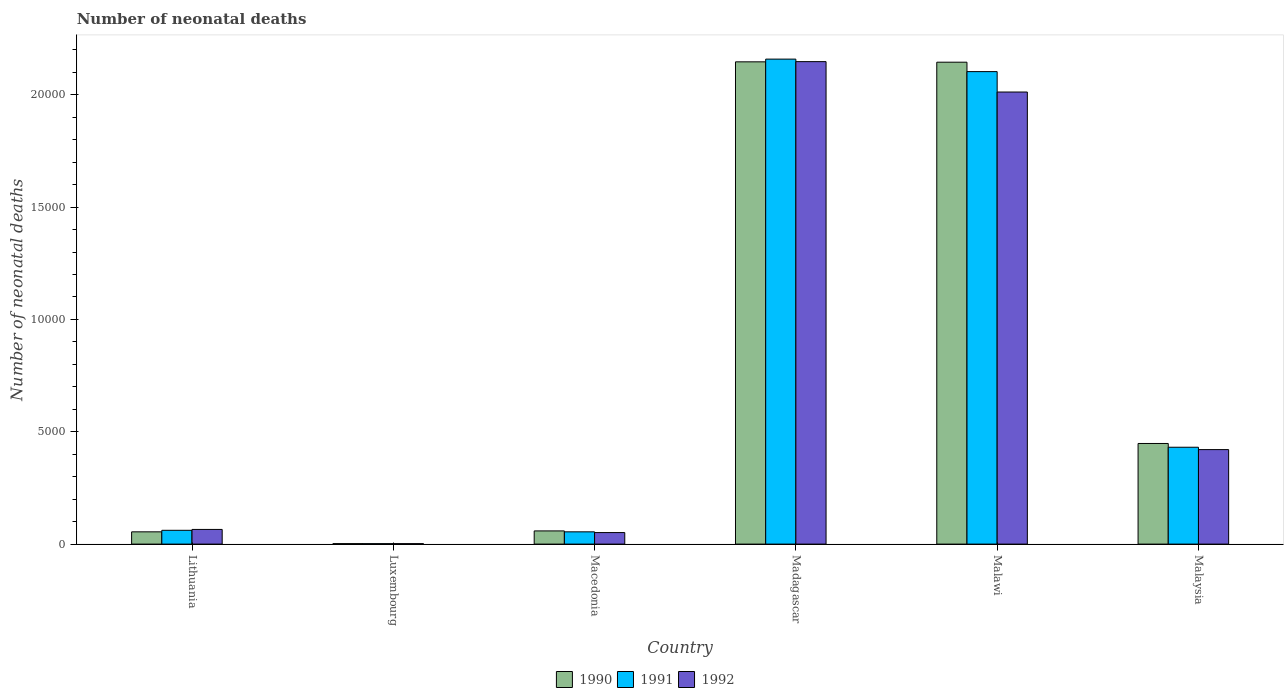How many different coloured bars are there?
Give a very brief answer. 3. How many bars are there on the 2nd tick from the right?
Keep it short and to the point. 3. What is the label of the 2nd group of bars from the left?
Ensure brevity in your answer.  Luxembourg. In how many cases, is the number of bars for a given country not equal to the number of legend labels?
Keep it short and to the point. 0. What is the number of neonatal deaths in in 1991 in Malawi?
Make the answer very short. 2.10e+04. Across all countries, what is the maximum number of neonatal deaths in in 1990?
Ensure brevity in your answer.  2.15e+04. Across all countries, what is the minimum number of neonatal deaths in in 1991?
Provide a succinct answer. 20. In which country was the number of neonatal deaths in in 1990 maximum?
Offer a very short reply. Madagascar. In which country was the number of neonatal deaths in in 1992 minimum?
Your response must be concise. Luxembourg. What is the total number of neonatal deaths in in 1991 in the graph?
Make the answer very short. 4.81e+04. What is the difference between the number of neonatal deaths in in 1990 in Luxembourg and that in Malawi?
Make the answer very short. -2.14e+04. What is the difference between the number of neonatal deaths in in 1991 in Macedonia and the number of neonatal deaths in in 1992 in Lithuania?
Your response must be concise. -107. What is the average number of neonatal deaths in in 1991 per country?
Give a very brief answer. 8017.83. What is the difference between the number of neonatal deaths in of/in 1991 and number of neonatal deaths in of/in 1990 in Malawi?
Provide a short and direct response. -419. In how many countries, is the number of neonatal deaths in in 1991 greater than 10000?
Provide a short and direct response. 2. What is the ratio of the number of neonatal deaths in in 1990 in Macedonia to that in Madagascar?
Your response must be concise. 0.03. Is the number of neonatal deaths in in 1992 in Lithuania less than that in Malawi?
Offer a terse response. Yes. Is the difference between the number of neonatal deaths in in 1991 in Lithuania and Madagascar greater than the difference between the number of neonatal deaths in in 1990 in Lithuania and Madagascar?
Provide a short and direct response. No. What is the difference between the highest and the second highest number of neonatal deaths in in 1990?
Your answer should be very brief. 16. What is the difference between the highest and the lowest number of neonatal deaths in in 1992?
Provide a succinct answer. 2.15e+04. Is the sum of the number of neonatal deaths in in 1990 in Madagascar and Malaysia greater than the maximum number of neonatal deaths in in 1991 across all countries?
Provide a succinct answer. Yes. Does the graph contain grids?
Give a very brief answer. No. How many legend labels are there?
Provide a succinct answer. 3. What is the title of the graph?
Provide a succinct answer. Number of neonatal deaths. Does "2002" appear as one of the legend labels in the graph?
Provide a short and direct response. No. What is the label or title of the X-axis?
Your answer should be very brief. Country. What is the label or title of the Y-axis?
Ensure brevity in your answer.  Number of neonatal deaths. What is the Number of neonatal deaths of 1990 in Lithuania?
Your answer should be very brief. 546. What is the Number of neonatal deaths in 1991 in Lithuania?
Your response must be concise. 614. What is the Number of neonatal deaths of 1992 in Lithuania?
Offer a terse response. 653. What is the Number of neonatal deaths of 1990 in Luxembourg?
Provide a short and direct response. 21. What is the Number of neonatal deaths in 1990 in Macedonia?
Provide a short and direct response. 587. What is the Number of neonatal deaths of 1991 in Macedonia?
Your answer should be compact. 546. What is the Number of neonatal deaths of 1992 in Macedonia?
Your response must be concise. 513. What is the Number of neonatal deaths in 1990 in Madagascar?
Provide a succinct answer. 2.15e+04. What is the Number of neonatal deaths in 1991 in Madagascar?
Provide a succinct answer. 2.16e+04. What is the Number of neonatal deaths in 1992 in Madagascar?
Offer a very short reply. 2.15e+04. What is the Number of neonatal deaths of 1990 in Malawi?
Your response must be concise. 2.14e+04. What is the Number of neonatal deaths in 1991 in Malawi?
Your answer should be very brief. 2.10e+04. What is the Number of neonatal deaths of 1992 in Malawi?
Give a very brief answer. 2.01e+04. What is the Number of neonatal deaths in 1990 in Malaysia?
Your answer should be compact. 4479. What is the Number of neonatal deaths of 1991 in Malaysia?
Keep it short and to the point. 4311. What is the Number of neonatal deaths in 1992 in Malaysia?
Your answer should be very brief. 4206. Across all countries, what is the maximum Number of neonatal deaths of 1990?
Ensure brevity in your answer.  2.15e+04. Across all countries, what is the maximum Number of neonatal deaths in 1991?
Provide a succinct answer. 2.16e+04. Across all countries, what is the maximum Number of neonatal deaths of 1992?
Your response must be concise. 2.15e+04. Across all countries, what is the minimum Number of neonatal deaths of 1990?
Offer a terse response. 21. Across all countries, what is the minimum Number of neonatal deaths of 1992?
Provide a short and direct response. 20. What is the total Number of neonatal deaths of 1990 in the graph?
Provide a short and direct response. 4.85e+04. What is the total Number of neonatal deaths in 1991 in the graph?
Keep it short and to the point. 4.81e+04. What is the total Number of neonatal deaths in 1992 in the graph?
Offer a very short reply. 4.70e+04. What is the difference between the Number of neonatal deaths of 1990 in Lithuania and that in Luxembourg?
Make the answer very short. 525. What is the difference between the Number of neonatal deaths of 1991 in Lithuania and that in Luxembourg?
Your response must be concise. 594. What is the difference between the Number of neonatal deaths of 1992 in Lithuania and that in Luxembourg?
Provide a short and direct response. 633. What is the difference between the Number of neonatal deaths of 1990 in Lithuania and that in Macedonia?
Provide a short and direct response. -41. What is the difference between the Number of neonatal deaths in 1992 in Lithuania and that in Macedonia?
Your answer should be compact. 140. What is the difference between the Number of neonatal deaths in 1990 in Lithuania and that in Madagascar?
Your answer should be compact. -2.09e+04. What is the difference between the Number of neonatal deaths of 1991 in Lithuania and that in Madagascar?
Provide a succinct answer. -2.10e+04. What is the difference between the Number of neonatal deaths of 1992 in Lithuania and that in Madagascar?
Offer a very short reply. -2.08e+04. What is the difference between the Number of neonatal deaths in 1990 in Lithuania and that in Malawi?
Provide a short and direct response. -2.09e+04. What is the difference between the Number of neonatal deaths of 1991 in Lithuania and that in Malawi?
Keep it short and to the point. -2.04e+04. What is the difference between the Number of neonatal deaths in 1992 in Lithuania and that in Malawi?
Your response must be concise. -1.95e+04. What is the difference between the Number of neonatal deaths of 1990 in Lithuania and that in Malaysia?
Make the answer very short. -3933. What is the difference between the Number of neonatal deaths in 1991 in Lithuania and that in Malaysia?
Make the answer very short. -3697. What is the difference between the Number of neonatal deaths in 1992 in Lithuania and that in Malaysia?
Offer a terse response. -3553. What is the difference between the Number of neonatal deaths of 1990 in Luxembourg and that in Macedonia?
Provide a succinct answer. -566. What is the difference between the Number of neonatal deaths in 1991 in Luxembourg and that in Macedonia?
Ensure brevity in your answer.  -526. What is the difference between the Number of neonatal deaths in 1992 in Luxembourg and that in Macedonia?
Keep it short and to the point. -493. What is the difference between the Number of neonatal deaths of 1990 in Luxembourg and that in Madagascar?
Your response must be concise. -2.14e+04. What is the difference between the Number of neonatal deaths in 1991 in Luxembourg and that in Madagascar?
Your answer should be very brief. -2.16e+04. What is the difference between the Number of neonatal deaths in 1992 in Luxembourg and that in Madagascar?
Keep it short and to the point. -2.15e+04. What is the difference between the Number of neonatal deaths in 1990 in Luxembourg and that in Malawi?
Provide a succinct answer. -2.14e+04. What is the difference between the Number of neonatal deaths of 1991 in Luxembourg and that in Malawi?
Your answer should be compact. -2.10e+04. What is the difference between the Number of neonatal deaths of 1992 in Luxembourg and that in Malawi?
Ensure brevity in your answer.  -2.01e+04. What is the difference between the Number of neonatal deaths of 1990 in Luxembourg and that in Malaysia?
Make the answer very short. -4458. What is the difference between the Number of neonatal deaths of 1991 in Luxembourg and that in Malaysia?
Your answer should be very brief. -4291. What is the difference between the Number of neonatal deaths in 1992 in Luxembourg and that in Malaysia?
Make the answer very short. -4186. What is the difference between the Number of neonatal deaths of 1990 in Macedonia and that in Madagascar?
Provide a short and direct response. -2.09e+04. What is the difference between the Number of neonatal deaths of 1991 in Macedonia and that in Madagascar?
Provide a short and direct response. -2.10e+04. What is the difference between the Number of neonatal deaths in 1992 in Macedonia and that in Madagascar?
Offer a very short reply. -2.10e+04. What is the difference between the Number of neonatal deaths of 1990 in Macedonia and that in Malawi?
Make the answer very short. -2.09e+04. What is the difference between the Number of neonatal deaths of 1991 in Macedonia and that in Malawi?
Your response must be concise. -2.05e+04. What is the difference between the Number of neonatal deaths of 1992 in Macedonia and that in Malawi?
Make the answer very short. -1.96e+04. What is the difference between the Number of neonatal deaths of 1990 in Macedonia and that in Malaysia?
Your response must be concise. -3892. What is the difference between the Number of neonatal deaths in 1991 in Macedonia and that in Malaysia?
Your answer should be very brief. -3765. What is the difference between the Number of neonatal deaths in 1992 in Macedonia and that in Malaysia?
Offer a very short reply. -3693. What is the difference between the Number of neonatal deaths of 1991 in Madagascar and that in Malawi?
Provide a succinct answer. 556. What is the difference between the Number of neonatal deaths of 1992 in Madagascar and that in Malawi?
Your answer should be compact. 1352. What is the difference between the Number of neonatal deaths of 1990 in Madagascar and that in Malaysia?
Provide a short and direct response. 1.70e+04. What is the difference between the Number of neonatal deaths of 1991 in Madagascar and that in Malaysia?
Provide a succinct answer. 1.73e+04. What is the difference between the Number of neonatal deaths in 1992 in Madagascar and that in Malaysia?
Keep it short and to the point. 1.73e+04. What is the difference between the Number of neonatal deaths of 1990 in Malawi and that in Malaysia?
Offer a very short reply. 1.70e+04. What is the difference between the Number of neonatal deaths of 1991 in Malawi and that in Malaysia?
Offer a terse response. 1.67e+04. What is the difference between the Number of neonatal deaths of 1992 in Malawi and that in Malaysia?
Keep it short and to the point. 1.59e+04. What is the difference between the Number of neonatal deaths in 1990 in Lithuania and the Number of neonatal deaths in 1991 in Luxembourg?
Give a very brief answer. 526. What is the difference between the Number of neonatal deaths of 1990 in Lithuania and the Number of neonatal deaths of 1992 in Luxembourg?
Offer a very short reply. 526. What is the difference between the Number of neonatal deaths of 1991 in Lithuania and the Number of neonatal deaths of 1992 in Luxembourg?
Provide a succinct answer. 594. What is the difference between the Number of neonatal deaths in 1990 in Lithuania and the Number of neonatal deaths in 1991 in Macedonia?
Give a very brief answer. 0. What is the difference between the Number of neonatal deaths in 1991 in Lithuania and the Number of neonatal deaths in 1992 in Macedonia?
Provide a short and direct response. 101. What is the difference between the Number of neonatal deaths in 1990 in Lithuania and the Number of neonatal deaths in 1991 in Madagascar?
Your answer should be very brief. -2.10e+04. What is the difference between the Number of neonatal deaths in 1990 in Lithuania and the Number of neonatal deaths in 1992 in Madagascar?
Give a very brief answer. -2.09e+04. What is the difference between the Number of neonatal deaths in 1991 in Lithuania and the Number of neonatal deaths in 1992 in Madagascar?
Make the answer very short. -2.09e+04. What is the difference between the Number of neonatal deaths in 1990 in Lithuania and the Number of neonatal deaths in 1991 in Malawi?
Give a very brief answer. -2.05e+04. What is the difference between the Number of neonatal deaths of 1990 in Lithuania and the Number of neonatal deaths of 1992 in Malawi?
Offer a very short reply. -1.96e+04. What is the difference between the Number of neonatal deaths in 1991 in Lithuania and the Number of neonatal deaths in 1992 in Malawi?
Your answer should be very brief. -1.95e+04. What is the difference between the Number of neonatal deaths in 1990 in Lithuania and the Number of neonatal deaths in 1991 in Malaysia?
Give a very brief answer. -3765. What is the difference between the Number of neonatal deaths of 1990 in Lithuania and the Number of neonatal deaths of 1992 in Malaysia?
Offer a very short reply. -3660. What is the difference between the Number of neonatal deaths in 1991 in Lithuania and the Number of neonatal deaths in 1992 in Malaysia?
Your answer should be compact. -3592. What is the difference between the Number of neonatal deaths of 1990 in Luxembourg and the Number of neonatal deaths of 1991 in Macedonia?
Provide a succinct answer. -525. What is the difference between the Number of neonatal deaths in 1990 in Luxembourg and the Number of neonatal deaths in 1992 in Macedonia?
Your answer should be compact. -492. What is the difference between the Number of neonatal deaths of 1991 in Luxembourg and the Number of neonatal deaths of 1992 in Macedonia?
Keep it short and to the point. -493. What is the difference between the Number of neonatal deaths of 1990 in Luxembourg and the Number of neonatal deaths of 1991 in Madagascar?
Provide a succinct answer. -2.16e+04. What is the difference between the Number of neonatal deaths in 1990 in Luxembourg and the Number of neonatal deaths in 1992 in Madagascar?
Give a very brief answer. -2.15e+04. What is the difference between the Number of neonatal deaths in 1991 in Luxembourg and the Number of neonatal deaths in 1992 in Madagascar?
Your response must be concise. -2.15e+04. What is the difference between the Number of neonatal deaths of 1990 in Luxembourg and the Number of neonatal deaths of 1991 in Malawi?
Provide a short and direct response. -2.10e+04. What is the difference between the Number of neonatal deaths of 1990 in Luxembourg and the Number of neonatal deaths of 1992 in Malawi?
Make the answer very short. -2.01e+04. What is the difference between the Number of neonatal deaths of 1991 in Luxembourg and the Number of neonatal deaths of 1992 in Malawi?
Ensure brevity in your answer.  -2.01e+04. What is the difference between the Number of neonatal deaths of 1990 in Luxembourg and the Number of neonatal deaths of 1991 in Malaysia?
Keep it short and to the point. -4290. What is the difference between the Number of neonatal deaths in 1990 in Luxembourg and the Number of neonatal deaths in 1992 in Malaysia?
Ensure brevity in your answer.  -4185. What is the difference between the Number of neonatal deaths of 1991 in Luxembourg and the Number of neonatal deaths of 1992 in Malaysia?
Provide a short and direct response. -4186. What is the difference between the Number of neonatal deaths in 1990 in Macedonia and the Number of neonatal deaths in 1991 in Madagascar?
Your answer should be compact. -2.10e+04. What is the difference between the Number of neonatal deaths of 1990 in Macedonia and the Number of neonatal deaths of 1992 in Madagascar?
Offer a very short reply. -2.09e+04. What is the difference between the Number of neonatal deaths of 1991 in Macedonia and the Number of neonatal deaths of 1992 in Madagascar?
Give a very brief answer. -2.09e+04. What is the difference between the Number of neonatal deaths in 1990 in Macedonia and the Number of neonatal deaths in 1991 in Malawi?
Offer a terse response. -2.04e+04. What is the difference between the Number of neonatal deaths of 1990 in Macedonia and the Number of neonatal deaths of 1992 in Malawi?
Make the answer very short. -1.95e+04. What is the difference between the Number of neonatal deaths of 1991 in Macedonia and the Number of neonatal deaths of 1992 in Malawi?
Ensure brevity in your answer.  -1.96e+04. What is the difference between the Number of neonatal deaths of 1990 in Macedonia and the Number of neonatal deaths of 1991 in Malaysia?
Your answer should be very brief. -3724. What is the difference between the Number of neonatal deaths in 1990 in Macedonia and the Number of neonatal deaths in 1992 in Malaysia?
Offer a very short reply. -3619. What is the difference between the Number of neonatal deaths in 1991 in Macedonia and the Number of neonatal deaths in 1992 in Malaysia?
Your answer should be compact. -3660. What is the difference between the Number of neonatal deaths of 1990 in Madagascar and the Number of neonatal deaths of 1991 in Malawi?
Keep it short and to the point. 435. What is the difference between the Number of neonatal deaths in 1990 in Madagascar and the Number of neonatal deaths in 1992 in Malawi?
Give a very brief answer. 1343. What is the difference between the Number of neonatal deaths of 1991 in Madagascar and the Number of neonatal deaths of 1992 in Malawi?
Ensure brevity in your answer.  1464. What is the difference between the Number of neonatal deaths of 1990 in Madagascar and the Number of neonatal deaths of 1991 in Malaysia?
Offer a very short reply. 1.72e+04. What is the difference between the Number of neonatal deaths in 1990 in Madagascar and the Number of neonatal deaths in 1992 in Malaysia?
Your answer should be compact. 1.73e+04. What is the difference between the Number of neonatal deaths of 1991 in Madagascar and the Number of neonatal deaths of 1992 in Malaysia?
Ensure brevity in your answer.  1.74e+04. What is the difference between the Number of neonatal deaths in 1990 in Malawi and the Number of neonatal deaths in 1991 in Malaysia?
Your answer should be compact. 1.71e+04. What is the difference between the Number of neonatal deaths in 1990 in Malawi and the Number of neonatal deaths in 1992 in Malaysia?
Provide a succinct answer. 1.72e+04. What is the difference between the Number of neonatal deaths in 1991 in Malawi and the Number of neonatal deaths in 1992 in Malaysia?
Give a very brief answer. 1.68e+04. What is the average Number of neonatal deaths in 1990 per country?
Your answer should be very brief. 8091.17. What is the average Number of neonatal deaths in 1991 per country?
Provide a short and direct response. 8017.83. What is the average Number of neonatal deaths in 1992 per country?
Your answer should be compact. 7831.33. What is the difference between the Number of neonatal deaths in 1990 and Number of neonatal deaths in 1991 in Lithuania?
Your response must be concise. -68. What is the difference between the Number of neonatal deaths of 1990 and Number of neonatal deaths of 1992 in Lithuania?
Offer a terse response. -107. What is the difference between the Number of neonatal deaths in 1991 and Number of neonatal deaths in 1992 in Lithuania?
Your answer should be compact. -39. What is the difference between the Number of neonatal deaths in 1990 and Number of neonatal deaths in 1991 in Luxembourg?
Provide a short and direct response. 1. What is the difference between the Number of neonatal deaths of 1990 and Number of neonatal deaths of 1991 in Macedonia?
Ensure brevity in your answer.  41. What is the difference between the Number of neonatal deaths in 1990 and Number of neonatal deaths in 1991 in Madagascar?
Offer a very short reply. -121. What is the difference between the Number of neonatal deaths in 1990 and Number of neonatal deaths in 1992 in Madagascar?
Offer a terse response. -9. What is the difference between the Number of neonatal deaths of 1991 and Number of neonatal deaths of 1992 in Madagascar?
Offer a terse response. 112. What is the difference between the Number of neonatal deaths in 1990 and Number of neonatal deaths in 1991 in Malawi?
Make the answer very short. 419. What is the difference between the Number of neonatal deaths in 1990 and Number of neonatal deaths in 1992 in Malawi?
Keep it short and to the point. 1327. What is the difference between the Number of neonatal deaths in 1991 and Number of neonatal deaths in 1992 in Malawi?
Keep it short and to the point. 908. What is the difference between the Number of neonatal deaths of 1990 and Number of neonatal deaths of 1991 in Malaysia?
Make the answer very short. 168. What is the difference between the Number of neonatal deaths in 1990 and Number of neonatal deaths in 1992 in Malaysia?
Your answer should be very brief. 273. What is the difference between the Number of neonatal deaths of 1991 and Number of neonatal deaths of 1992 in Malaysia?
Provide a short and direct response. 105. What is the ratio of the Number of neonatal deaths in 1991 in Lithuania to that in Luxembourg?
Offer a very short reply. 30.7. What is the ratio of the Number of neonatal deaths in 1992 in Lithuania to that in Luxembourg?
Give a very brief answer. 32.65. What is the ratio of the Number of neonatal deaths in 1990 in Lithuania to that in Macedonia?
Make the answer very short. 0.93. What is the ratio of the Number of neonatal deaths in 1991 in Lithuania to that in Macedonia?
Your response must be concise. 1.12. What is the ratio of the Number of neonatal deaths in 1992 in Lithuania to that in Macedonia?
Make the answer very short. 1.27. What is the ratio of the Number of neonatal deaths of 1990 in Lithuania to that in Madagascar?
Offer a very short reply. 0.03. What is the ratio of the Number of neonatal deaths in 1991 in Lithuania to that in Madagascar?
Provide a short and direct response. 0.03. What is the ratio of the Number of neonatal deaths of 1992 in Lithuania to that in Madagascar?
Your answer should be compact. 0.03. What is the ratio of the Number of neonatal deaths of 1990 in Lithuania to that in Malawi?
Provide a succinct answer. 0.03. What is the ratio of the Number of neonatal deaths of 1991 in Lithuania to that in Malawi?
Give a very brief answer. 0.03. What is the ratio of the Number of neonatal deaths in 1992 in Lithuania to that in Malawi?
Your answer should be very brief. 0.03. What is the ratio of the Number of neonatal deaths in 1990 in Lithuania to that in Malaysia?
Offer a very short reply. 0.12. What is the ratio of the Number of neonatal deaths in 1991 in Lithuania to that in Malaysia?
Ensure brevity in your answer.  0.14. What is the ratio of the Number of neonatal deaths of 1992 in Lithuania to that in Malaysia?
Provide a short and direct response. 0.16. What is the ratio of the Number of neonatal deaths of 1990 in Luxembourg to that in Macedonia?
Offer a terse response. 0.04. What is the ratio of the Number of neonatal deaths of 1991 in Luxembourg to that in Macedonia?
Your answer should be compact. 0.04. What is the ratio of the Number of neonatal deaths of 1992 in Luxembourg to that in Macedonia?
Keep it short and to the point. 0.04. What is the ratio of the Number of neonatal deaths of 1991 in Luxembourg to that in Madagascar?
Your answer should be very brief. 0. What is the ratio of the Number of neonatal deaths of 1992 in Luxembourg to that in Madagascar?
Keep it short and to the point. 0. What is the ratio of the Number of neonatal deaths of 1990 in Luxembourg to that in Malawi?
Keep it short and to the point. 0. What is the ratio of the Number of neonatal deaths of 1991 in Luxembourg to that in Malawi?
Give a very brief answer. 0. What is the ratio of the Number of neonatal deaths in 1990 in Luxembourg to that in Malaysia?
Offer a very short reply. 0. What is the ratio of the Number of neonatal deaths in 1991 in Luxembourg to that in Malaysia?
Give a very brief answer. 0. What is the ratio of the Number of neonatal deaths of 1992 in Luxembourg to that in Malaysia?
Your answer should be very brief. 0. What is the ratio of the Number of neonatal deaths in 1990 in Macedonia to that in Madagascar?
Provide a succinct answer. 0.03. What is the ratio of the Number of neonatal deaths of 1991 in Macedonia to that in Madagascar?
Your answer should be very brief. 0.03. What is the ratio of the Number of neonatal deaths in 1992 in Macedonia to that in Madagascar?
Provide a succinct answer. 0.02. What is the ratio of the Number of neonatal deaths of 1990 in Macedonia to that in Malawi?
Your answer should be compact. 0.03. What is the ratio of the Number of neonatal deaths in 1991 in Macedonia to that in Malawi?
Your answer should be compact. 0.03. What is the ratio of the Number of neonatal deaths of 1992 in Macedonia to that in Malawi?
Offer a terse response. 0.03. What is the ratio of the Number of neonatal deaths of 1990 in Macedonia to that in Malaysia?
Your answer should be compact. 0.13. What is the ratio of the Number of neonatal deaths of 1991 in Macedonia to that in Malaysia?
Offer a terse response. 0.13. What is the ratio of the Number of neonatal deaths of 1992 in Macedonia to that in Malaysia?
Provide a short and direct response. 0.12. What is the ratio of the Number of neonatal deaths of 1991 in Madagascar to that in Malawi?
Your answer should be very brief. 1.03. What is the ratio of the Number of neonatal deaths of 1992 in Madagascar to that in Malawi?
Your response must be concise. 1.07. What is the ratio of the Number of neonatal deaths in 1990 in Madagascar to that in Malaysia?
Keep it short and to the point. 4.79. What is the ratio of the Number of neonatal deaths of 1991 in Madagascar to that in Malaysia?
Offer a terse response. 5.01. What is the ratio of the Number of neonatal deaths in 1992 in Madagascar to that in Malaysia?
Offer a very short reply. 5.11. What is the ratio of the Number of neonatal deaths in 1990 in Malawi to that in Malaysia?
Make the answer very short. 4.79. What is the ratio of the Number of neonatal deaths of 1991 in Malawi to that in Malaysia?
Offer a terse response. 4.88. What is the ratio of the Number of neonatal deaths of 1992 in Malawi to that in Malaysia?
Offer a terse response. 4.78. What is the difference between the highest and the second highest Number of neonatal deaths in 1991?
Offer a very short reply. 556. What is the difference between the highest and the second highest Number of neonatal deaths of 1992?
Keep it short and to the point. 1352. What is the difference between the highest and the lowest Number of neonatal deaths of 1990?
Offer a terse response. 2.14e+04. What is the difference between the highest and the lowest Number of neonatal deaths in 1991?
Keep it short and to the point. 2.16e+04. What is the difference between the highest and the lowest Number of neonatal deaths of 1992?
Offer a very short reply. 2.15e+04. 